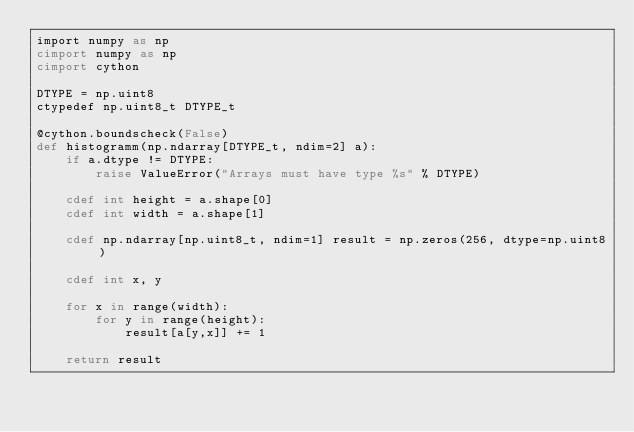Convert code to text. <code><loc_0><loc_0><loc_500><loc_500><_Cython_>import numpy as np
cimport numpy as np
cimport cython

DTYPE = np.uint8
ctypedef np.uint8_t DTYPE_t

@cython.boundscheck(False)
def histogramm(np.ndarray[DTYPE_t, ndim=2] a):
    if a.dtype != DTYPE:
        raise ValueError("Arrays must have type %s" % DTYPE)

    cdef int height = a.shape[0]
    cdef int width = a.shape[1]

    cdef np.ndarray[np.uint8_t, ndim=1] result = np.zeros(256, dtype=np.uint8)

    cdef int x, y

    for x in range(width):
        for y in range(height):
            result[a[y,x]] += 1

    return result</code> 